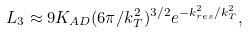Convert formula to latex. <formula><loc_0><loc_0><loc_500><loc_500>L _ { 3 } \approx 9 K _ { A D } ( 6 \pi / k _ { T } ^ { 2 } ) ^ { 3 / 2 } e ^ { - k _ { r e s } ^ { 2 } / k _ { T } ^ { 2 } } ,</formula> 